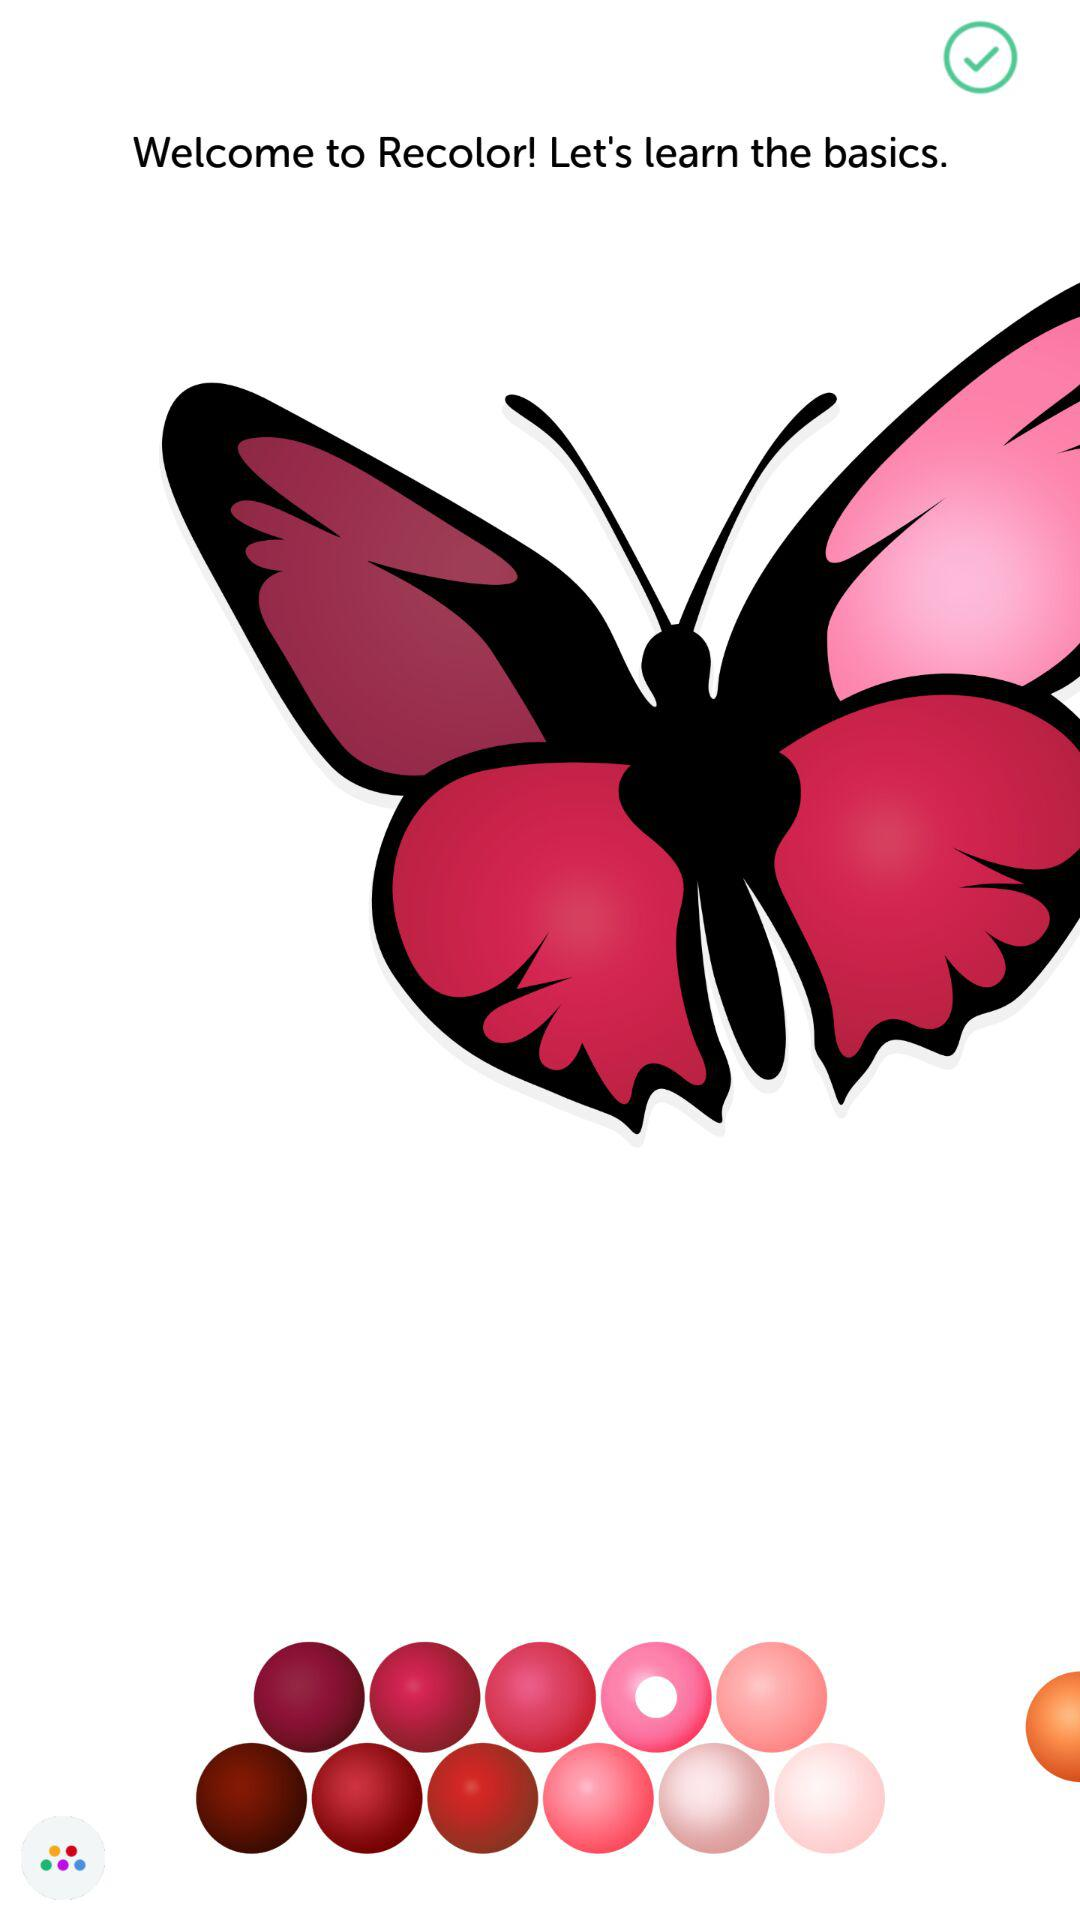What is the application name? The application name is "Recolor". 